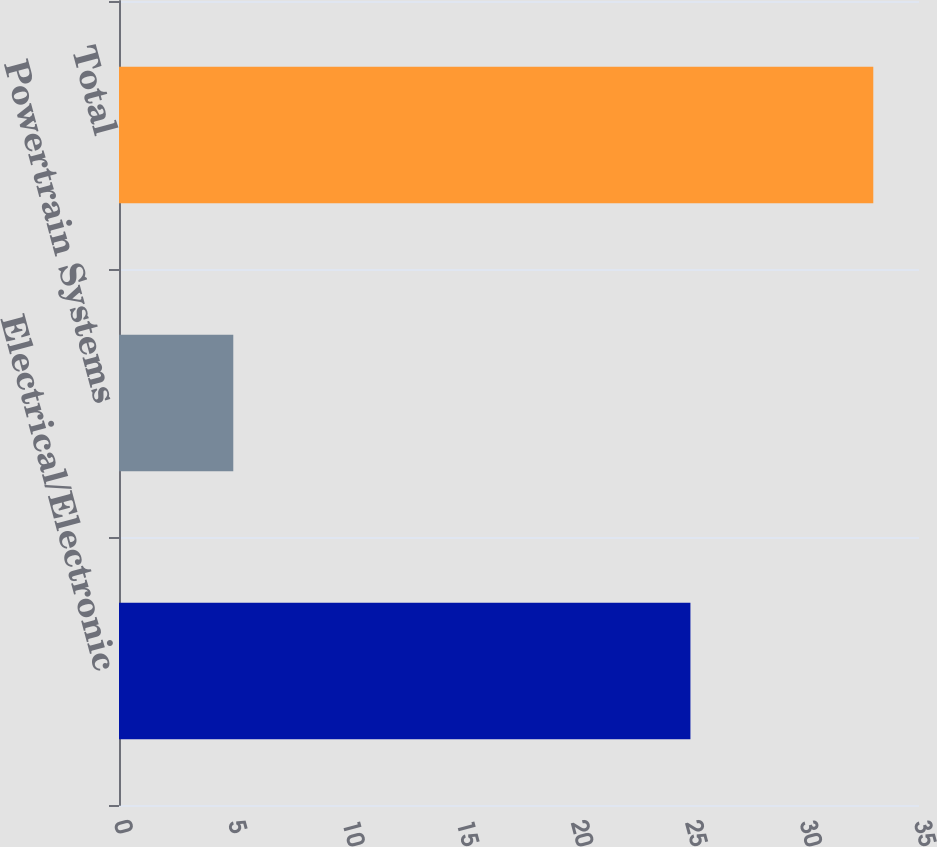Convert chart to OTSL. <chart><loc_0><loc_0><loc_500><loc_500><bar_chart><fcel>Electrical/Electronic<fcel>Powertrain Systems<fcel>Total<nl><fcel>25<fcel>5<fcel>33<nl></chart> 